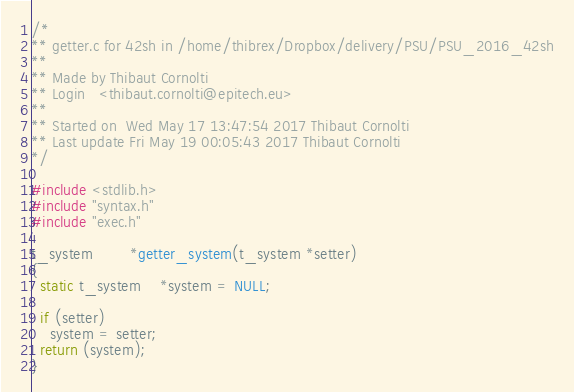Convert code to text. <code><loc_0><loc_0><loc_500><loc_500><_C_>/*
** getter.c for 42sh in /home/thibrex/Dropbox/delivery/PSU/PSU_2016_42sh
** 
** Made by Thibaut Cornolti
** Login   <thibaut.cornolti@epitech.eu>
** 
** Started on  Wed May 17 13:47:54 2017 Thibaut Cornolti
** Last update Fri May 19 00:05:43 2017 Thibaut Cornolti
*/

#include <stdlib.h>
#include "syntax.h"
#include "exec.h"

t_system		*getter_system(t_system *setter)
{
  static t_system	*system = NULL;

  if (setter)
    system = setter;
  return (system);
}
</code> 